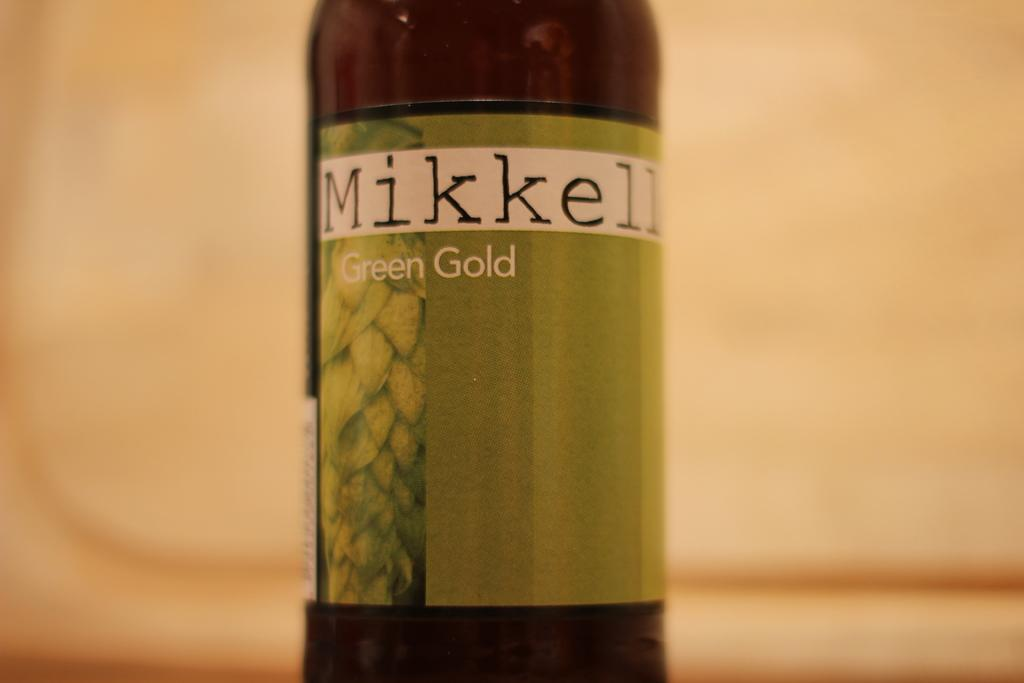<image>
Summarize the visual content of the image. A bottle of Mikkeller Green Gold beer stands on its own. 